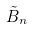Convert formula to latex. <formula><loc_0><loc_0><loc_500><loc_500>\tilde { B } _ { n }</formula> 